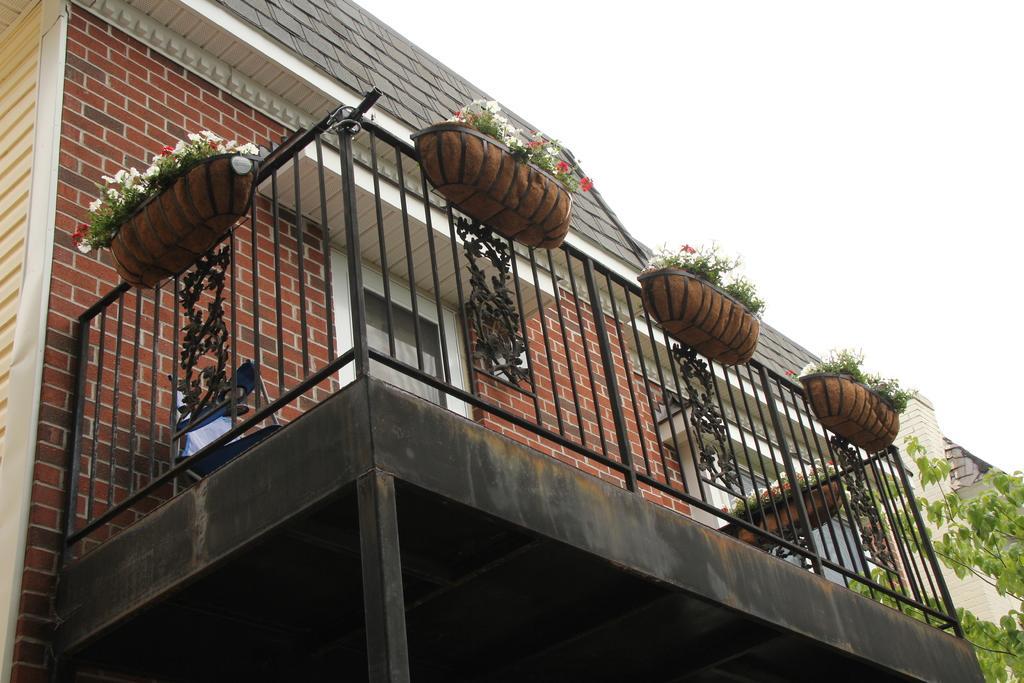Please provide a concise description of this image. In this image I can see a building, fence, house plants, tree and the sky. This image is taken may be during a day. 